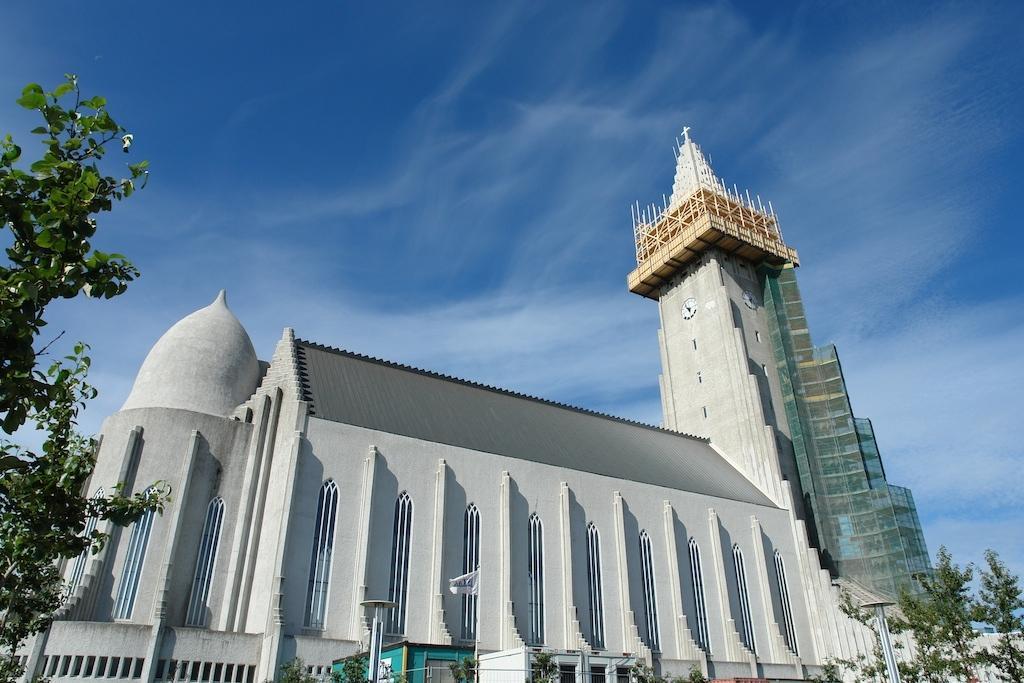Can you describe this image briefly? In this image we can see a building, trees, poles and other objects. In the background of the image there is the sky. On the left side of the image there is a tree. 